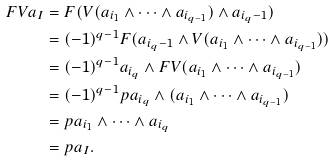<formula> <loc_0><loc_0><loc_500><loc_500>F V a _ { I } & = F ( V ( a _ { i _ { 1 } } \wedge \dots \wedge a _ { i _ { q - 1 } } ) \wedge a _ { i _ { q } - 1 } ) \\ & = ( - 1 ) ^ { q - 1 } F ( a _ { i _ { q } - 1 } \wedge V ( a _ { i _ { 1 } } \wedge \dots \wedge a _ { i _ { q - 1 } } ) ) \\ & = ( - 1 ) ^ { q - 1 } a _ { i _ { q } } \wedge F V ( a _ { i _ { 1 } } \wedge \dots \wedge a _ { i _ { q - 1 } } ) \\ & = ( - 1 ) ^ { q - 1 } p a _ { i _ { q } } \wedge ( a _ { i _ { 1 } } \wedge \dots \wedge a _ { i _ { q - 1 } } ) \\ & = p a _ { i _ { 1 } } \wedge \dots \wedge a _ { i _ { q } } \\ & = p a _ { I } .</formula> 